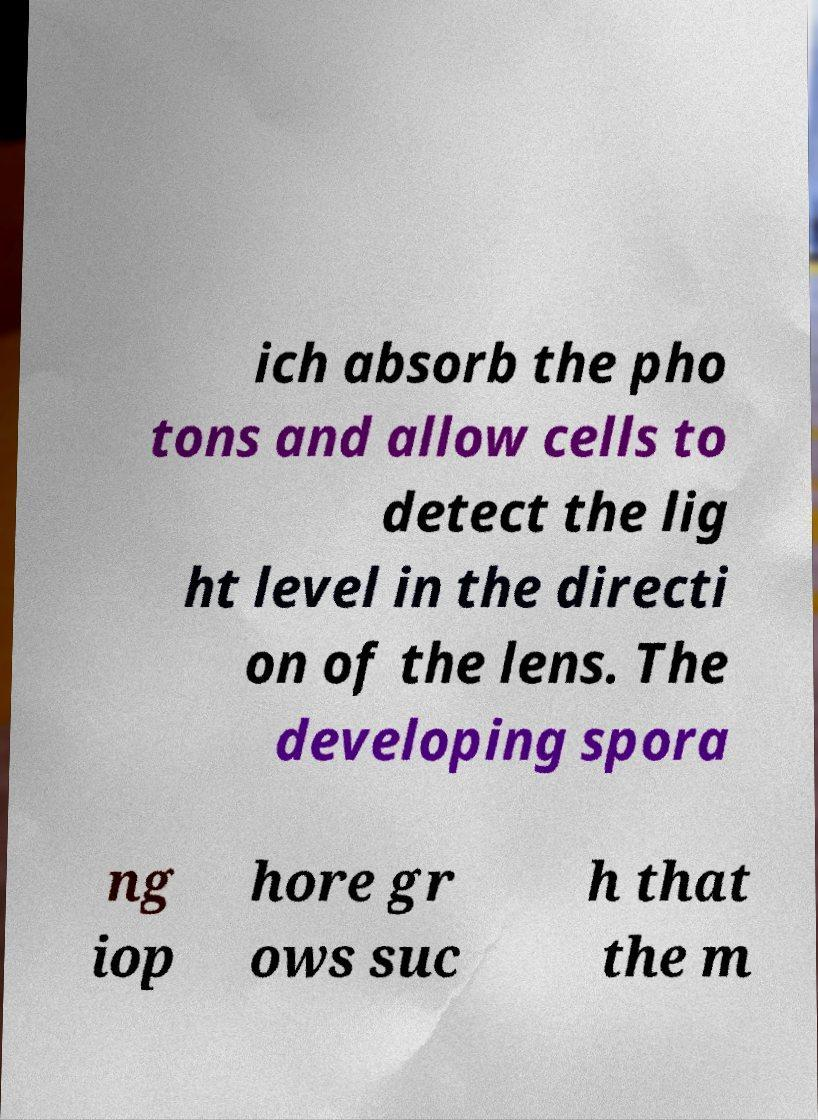Please read and relay the text visible in this image. What does it say? ich absorb the pho tons and allow cells to detect the lig ht level in the directi on of the lens. The developing spora ng iop hore gr ows suc h that the m 